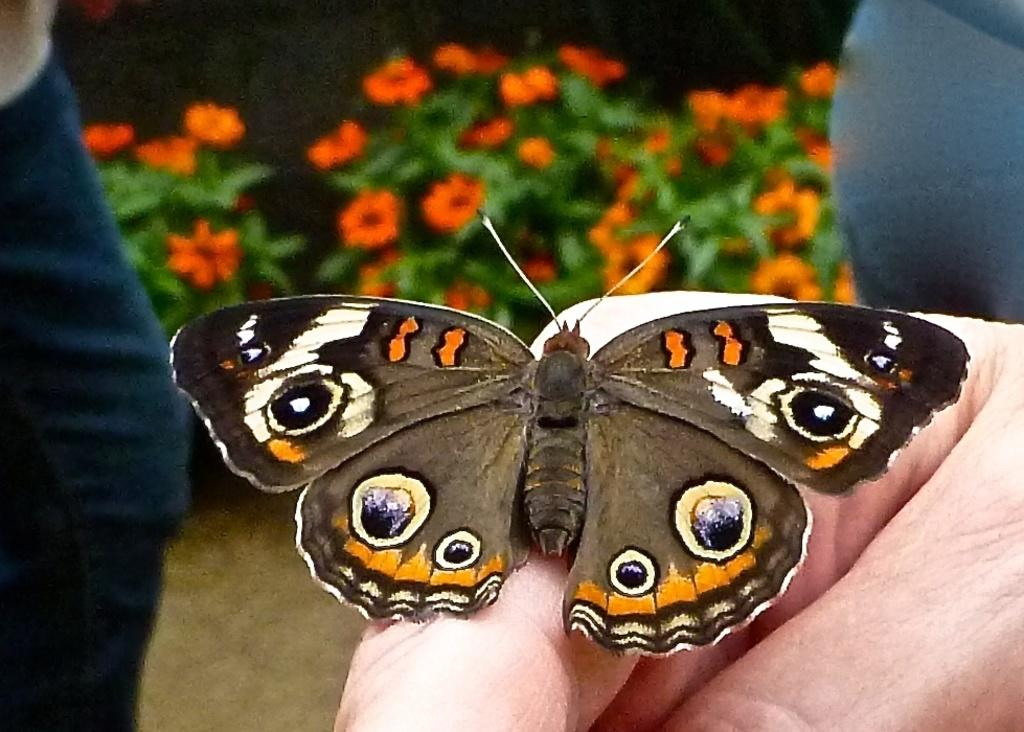What part of a person is visible in the image? A person's hand is visible in the image. What is on the person's hand? A butterfly is on the hand. Where is the person standing in the image? The person is standing on the land. What can be found on the land in the image? The land has plants with flowers and leaves. What type of print can be seen on the person's shirt in the image? There is no information about the person's shirt or any print on it in the provided facts. 